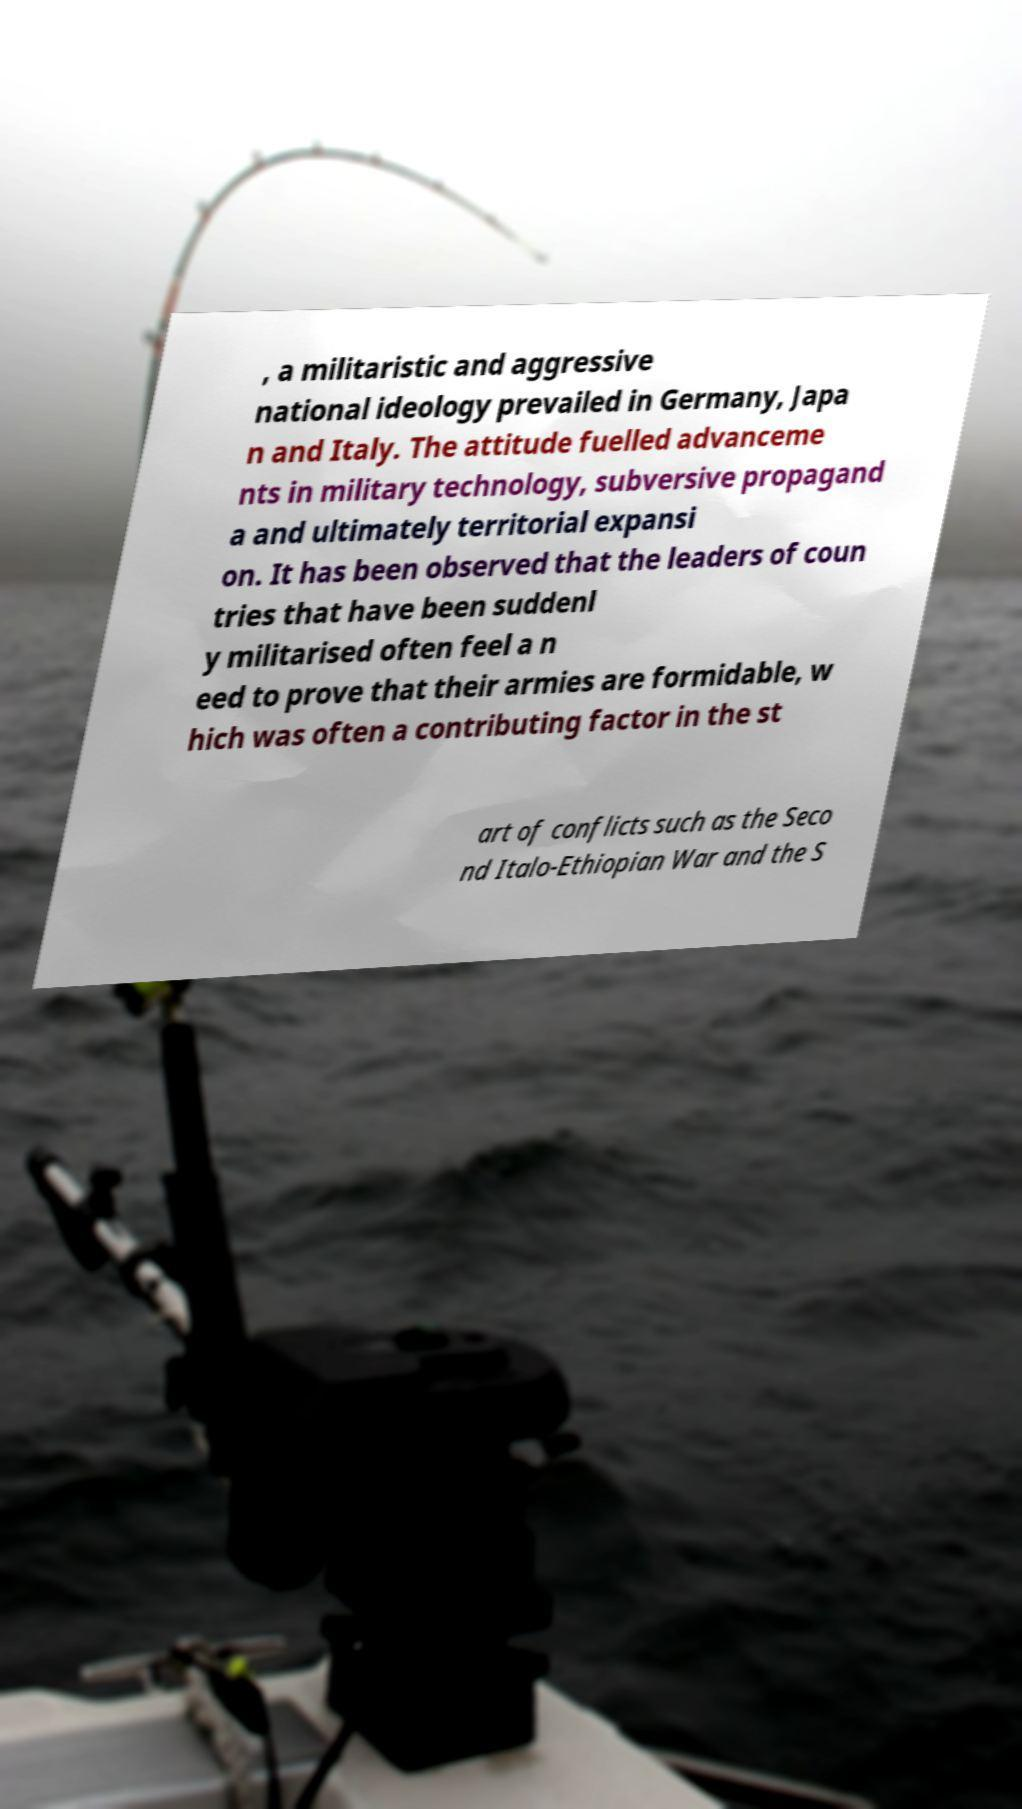Please identify and transcribe the text found in this image. , a militaristic and aggressive national ideology prevailed in Germany, Japa n and Italy. The attitude fuelled advanceme nts in military technology, subversive propagand a and ultimately territorial expansi on. It has been observed that the leaders of coun tries that have been suddenl y militarised often feel a n eed to prove that their armies are formidable, w hich was often a contributing factor in the st art of conflicts such as the Seco nd Italo-Ethiopian War and the S 